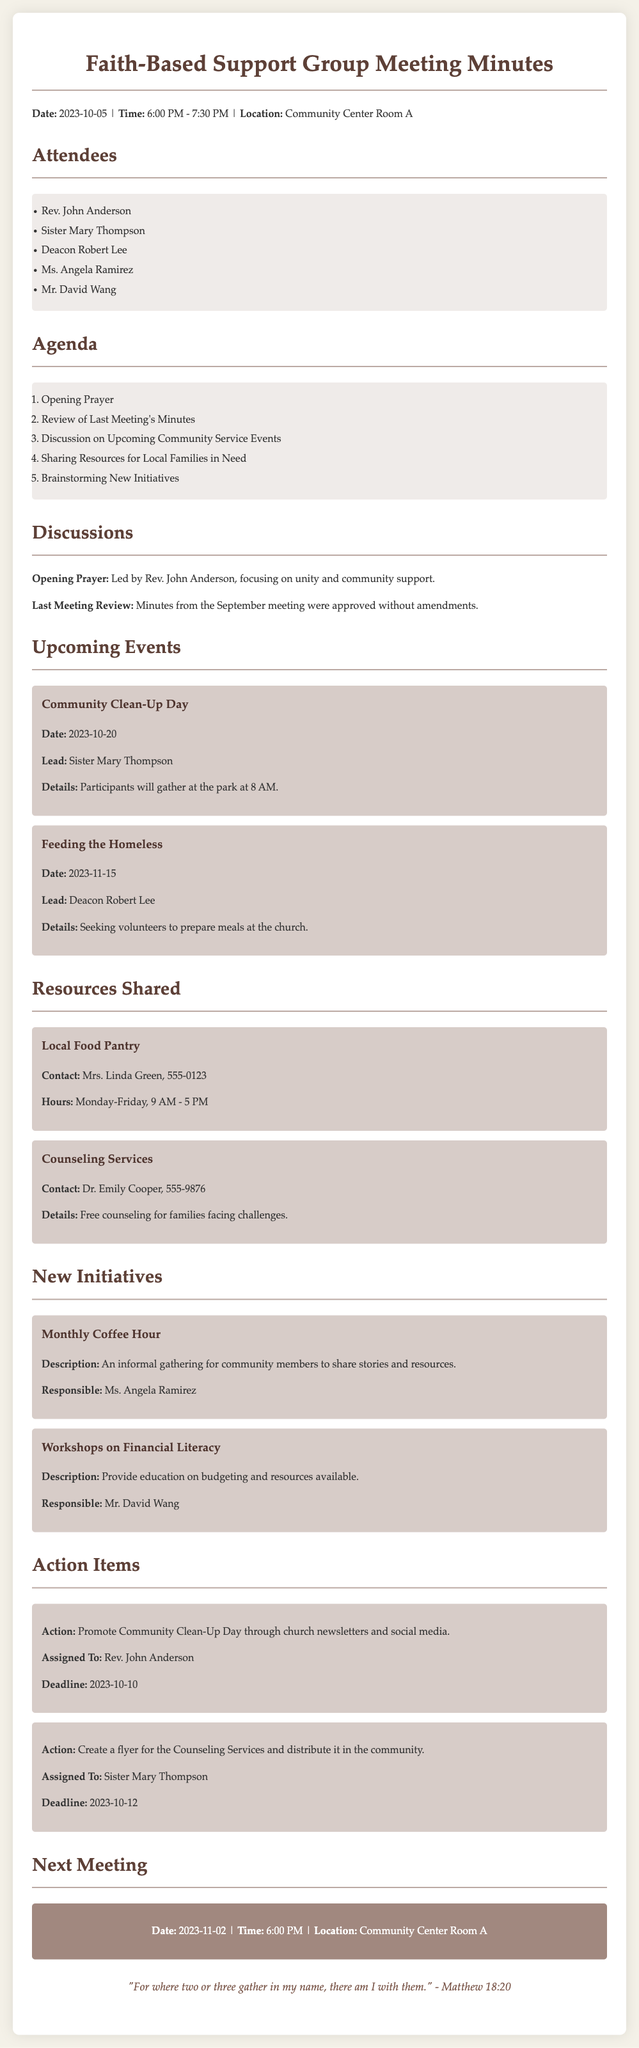What is the date of the next meeting? The next meeting date is explicitly stated in the document under the "Next Meeting" section.
Answer: 2023-11-02 Who led the opening prayer? The document specifies that Rev. John Anderson led the opening prayer during the meeting discussions.
Answer: Rev. John Anderson What is the time duration of the meeting? The time is mentioned at the beginning of the document, illustrating the start and end times of the meeting.
Answer: 6:00 PM - 7:30 PM What initiative is Ms. Angela Ramirez responsible for? The "New Initiatives" section indicates that Ms. Angela Ramirez is responsible for the Monthly Coffee Hour initiative.
Answer: Monthly Coffee Hour When is the Community Clean-Up Day scheduled? The event details specify the date for the Community Clean-Up Day within the "Upcoming Events" section.
Answer: 2023-10-20 What action is Rev. John Anderson assigned to? Under the "Action Items" section, it is clearly mentioned what specific action Rev. John Anderson is responsible for.
Answer: Promote Community Clean-Up Day How many attendees were present at the meeting? The list of attendees provides a clear count of participants who attended the meeting.
Answer: 5 What type of resource is provided by Dr. Emily Cooper? The document outlines the type of assistance offered by Dr. Emily Cooper in the "Resources Shared" section.
Answer: Counseling Services What will participants be doing during the Feeding the Homeless event? The details regarding the Feeding the Homeless event describe the activities that will take place.
Answer: Prepare meals 